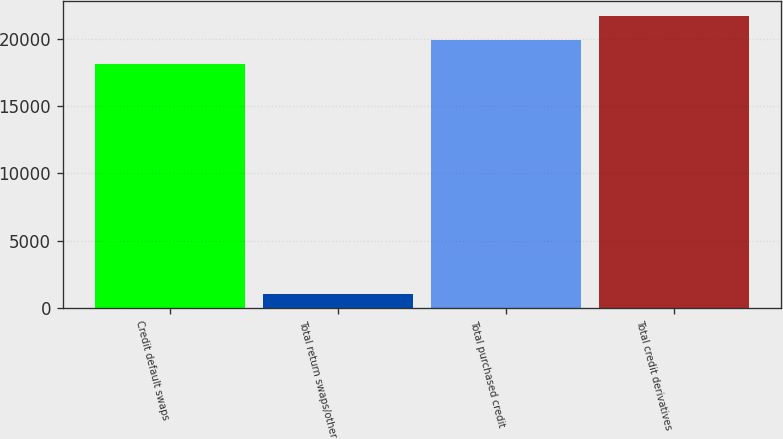Convert chart. <chart><loc_0><loc_0><loc_500><loc_500><bar_chart><fcel>Credit default swaps<fcel>Total return swaps/other<fcel>Total purchased credit<fcel>Total credit derivatives<nl><fcel>18150<fcel>1013<fcel>19965<fcel>21780<nl></chart> 